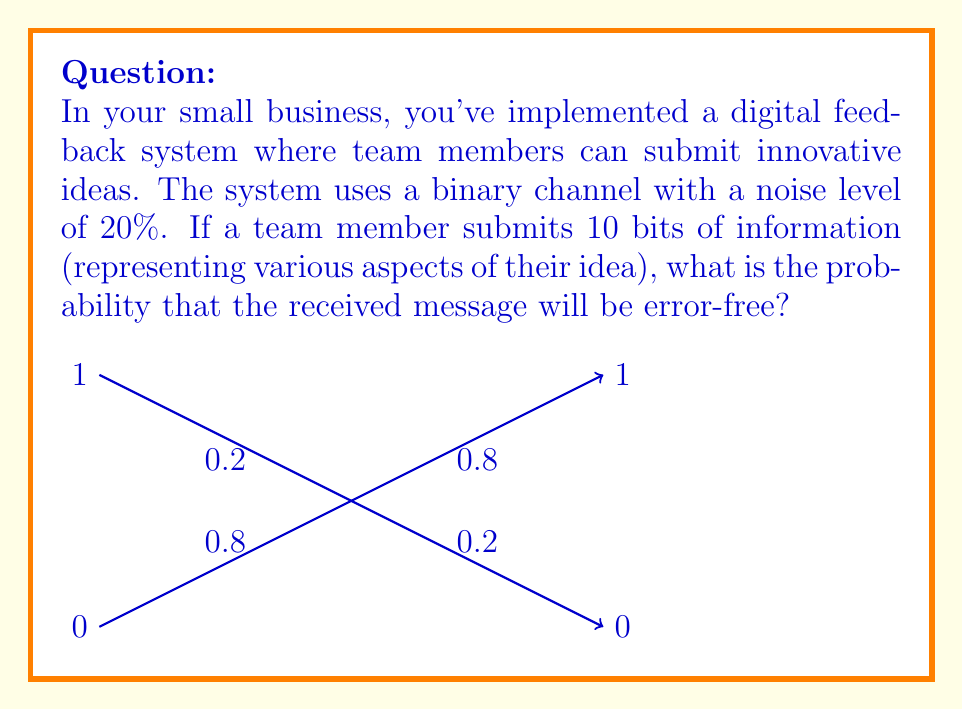Show me your answer to this math problem. Let's approach this step-by-step:

1) In a binary channel with 20% noise, each bit has:
   - 80% (0.8) probability of being transmitted correctly
   - 20% (0.2) probability of being flipped (error)

2) For the entire message to be error-free, each of the 10 bits must be transmitted correctly.

3) The probability of a single bit being correct is 0.8.

4) To find the probability of all 10 bits being correct, we multiply the individual probabilities:

   $$ P(\text{all correct}) = 0.8 \times 0.8 \times ... \times 0.8 \text{ (10 times)} $$

5) This can be written as:

   $$ P(\text{all correct}) = (0.8)^{10} $$

6) Calculate:
   $$ (0.8)^{10} = 0.1073741824 $$

7) Convert to a percentage:
   $$ 0.1073741824 \times 100\% \approx 10.74\% $$

Thus, there's approximately a 10.74% chance that a 10-bit message will be received without any errors in this system.
Answer: $10.74\%$ 